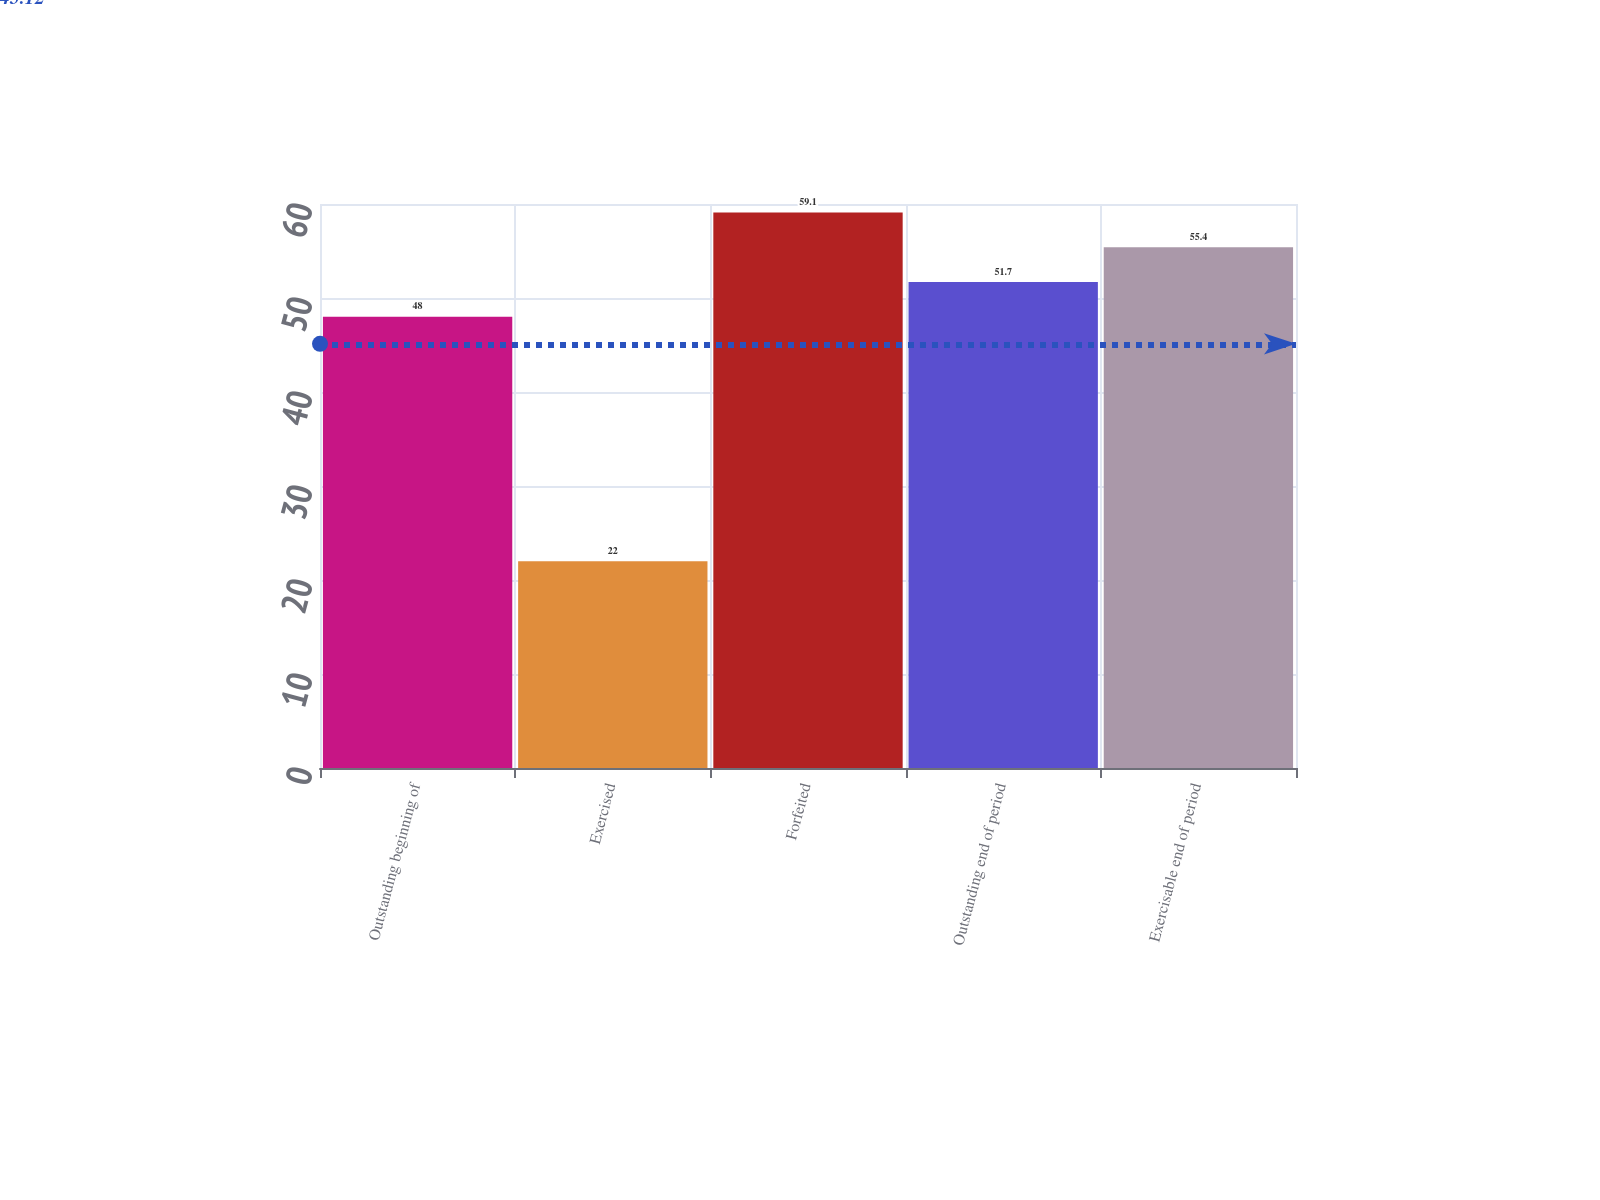Convert chart to OTSL. <chart><loc_0><loc_0><loc_500><loc_500><bar_chart><fcel>Outstanding beginning of<fcel>Exercised<fcel>Forfeited<fcel>Outstanding end of period<fcel>Exercisable end of period<nl><fcel>48<fcel>22<fcel>59.1<fcel>51.7<fcel>55.4<nl></chart> 